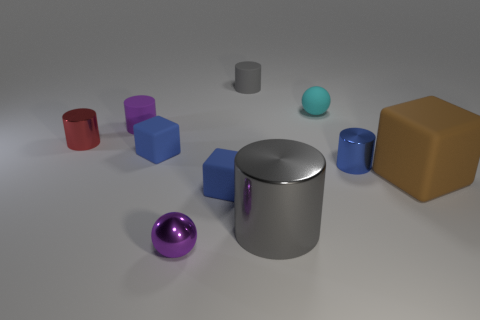Subtract all red metallic cylinders. How many cylinders are left? 4 Subtract all blue cylinders. How many cylinders are left? 4 Subtract all green cylinders. Subtract all purple balls. How many cylinders are left? 5 Subtract all blocks. How many objects are left? 7 Subtract 0 red blocks. How many objects are left? 10 Subtract all tiny purple rubber things. Subtract all red shiny things. How many objects are left? 8 Add 7 small metallic things. How many small metallic things are left? 10 Add 9 tiny gray blocks. How many tiny gray blocks exist? 9 